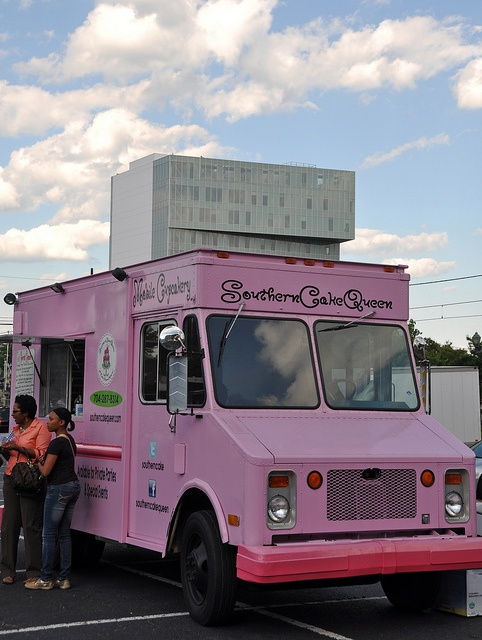Describe the objects in this image and their specific colors. I can see truck in darkgray, gray, and black tones, people in darkgray, black, brown, and maroon tones, people in darkgray, black, maroon, gray, and brown tones, handbag in darkgray, black, maroon, and brown tones, and handbag in darkgray, purple, and black tones in this image. 